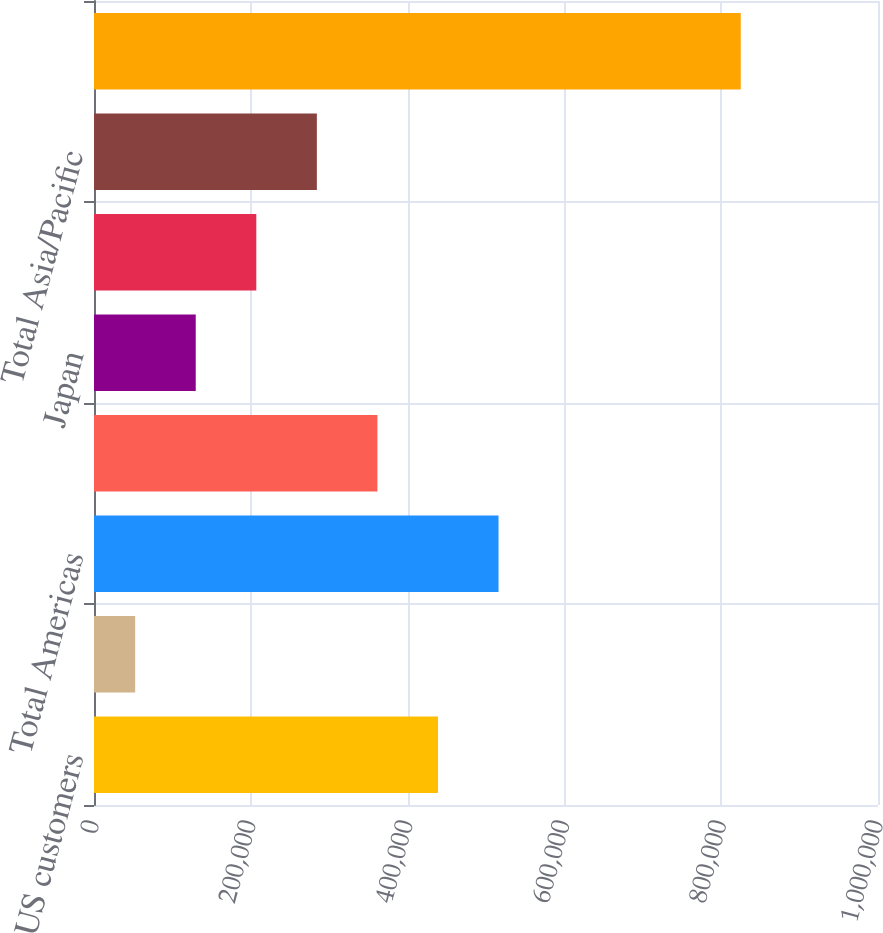Convert chart. <chart><loc_0><loc_0><loc_500><loc_500><bar_chart><fcel>US customers<fcel>Other Americas<fcel>Total Americas<fcel>Europe Middle East and Africa<fcel>Japan<fcel>Other Asia/Pacific<fcel>Total Asia/Pacific<fcel>Total net revenues<nl><fcel>438738<fcel>52530<fcel>515979<fcel>361496<fcel>129772<fcel>207013<fcel>284254<fcel>824945<nl></chart> 